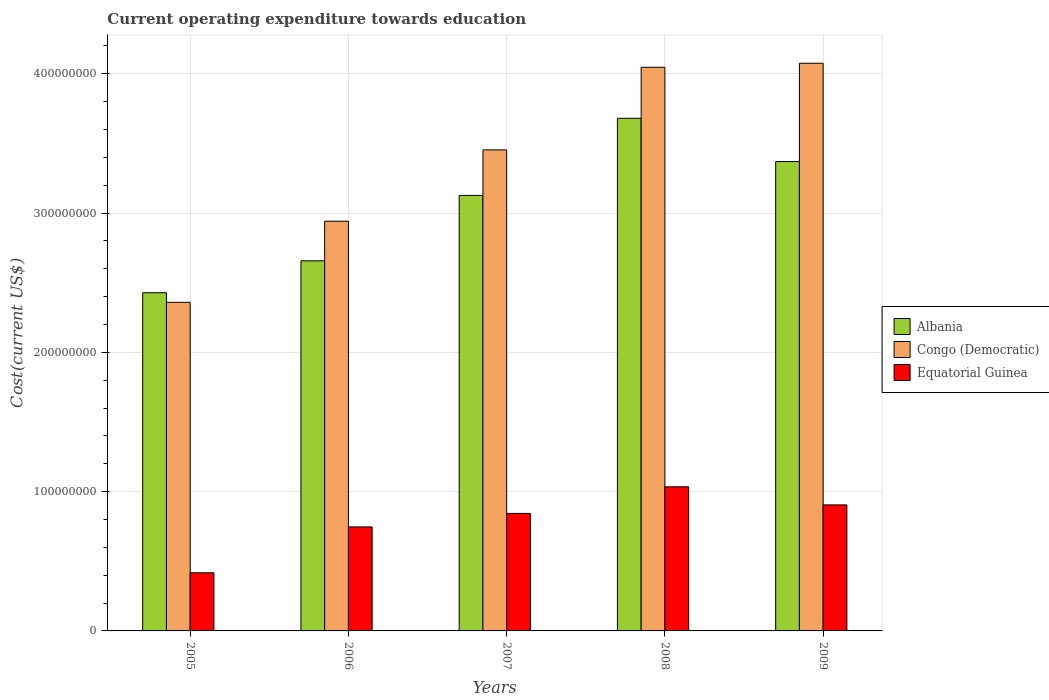How many different coloured bars are there?
Offer a very short reply. 3. How many groups of bars are there?
Give a very brief answer. 5. Are the number of bars per tick equal to the number of legend labels?
Offer a very short reply. Yes. How many bars are there on the 1st tick from the left?
Make the answer very short. 3. What is the label of the 4th group of bars from the left?
Provide a short and direct response. 2008. In how many cases, is the number of bars for a given year not equal to the number of legend labels?
Give a very brief answer. 0. What is the expenditure towards education in Congo (Democratic) in 2009?
Ensure brevity in your answer.  4.08e+08. Across all years, what is the maximum expenditure towards education in Equatorial Guinea?
Offer a terse response. 1.03e+08. Across all years, what is the minimum expenditure towards education in Equatorial Guinea?
Provide a succinct answer. 4.17e+07. In which year was the expenditure towards education in Congo (Democratic) maximum?
Ensure brevity in your answer.  2009. In which year was the expenditure towards education in Equatorial Guinea minimum?
Provide a short and direct response. 2005. What is the total expenditure towards education in Congo (Democratic) in the graph?
Your answer should be compact. 1.69e+09. What is the difference between the expenditure towards education in Albania in 2005 and that in 2007?
Make the answer very short. -6.98e+07. What is the difference between the expenditure towards education in Equatorial Guinea in 2008 and the expenditure towards education in Albania in 2005?
Keep it short and to the point. -1.39e+08. What is the average expenditure towards education in Equatorial Guinea per year?
Offer a terse response. 7.89e+07. In the year 2008, what is the difference between the expenditure towards education in Equatorial Guinea and expenditure towards education in Congo (Democratic)?
Provide a short and direct response. -3.01e+08. What is the ratio of the expenditure towards education in Albania in 2006 to that in 2009?
Your answer should be very brief. 0.79. Is the difference between the expenditure towards education in Equatorial Guinea in 2007 and 2008 greater than the difference between the expenditure towards education in Congo (Democratic) in 2007 and 2008?
Your response must be concise. Yes. What is the difference between the highest and the second highest expenditure towards education in Albania?
Provide a succinct answer. 3.11e+07. What is the difference between the highest and the lowest expenditure towards education in Albania?
Provide a short and direct response. 1.25e+08. Is the sum of the expenditure towards education in Albania in 2005 and 2008 greater than the maximum expenditure towards education in Equatorial Guinea across all years?
Your response must be concise. Yes. What does the 3rd bar from the left in 2007 represents?
Your response must be concise. Equatorial Guinea. What does the 2nd bar from the right in 2009 represents?
Keep it short and to the point. Congo (Democratic). Is it the case that in every year, the sum of the expenditure towards education in Congo (Democratic) and expenditure towards education in Albania is greater than the expenditure towards education in Equatorial Guinea?
Provide a succinct answer. Yes. How many bars are there?
Offer a very short reply. 15. Are all the bars in the graph horizontal?
Offer a very short reply. No. Are the values on the major ticks of Y-axis written in scientific E-notation?
Your answer should be very brief. No. Does the graph contain any zero values?
Your answer should be very brief. No. Does the graph contain grids?
Keep it short and to the point. Yes. Where does the legend appear in the graph?
Keep it short and to the point. Center right. How are the legend labels stacked?
Provide a succinct answer. Vertical. What is the title of the graph?
Ensure brevity in your answer.  Current operating expenditure towards education. Does "Netherlands" appear as one of the legend labels in the graph?
Offer a terse response. No. What is the label or title of the Y-axis?
Keep it short and to the point. Cost(current US$). What is the Cost(current US$) of Albania in 2005?
Your answer should be compact. 2.43e+08. What is the Cost(current US$) of Congo (Democratic) in 2005?
Provide a succinct answer. 2.36e+08. What is the Cost(current US$) in Equatorial Guinea in 2005?
Your answer should be compact. 4.17e+07. What is the Cost(current US$) in Albania in 2006?
Your response must be concise. 2.66e+08. What is the Cost(current US$) in Congo (Democratic) in 2006?
Ensure brevity in your answer.  2.94e+08. What is the Cost(current US$) in Equatorial Guinea in 2006?
Offer a very short reply. 7.47e+07. What is the Cost(current US$) in Albania in 2007?
Your answer should be very brief. 3.13e+08. What is the Cost(current US$) of Congo (Democratic) in 2007?
Offer a very short reply. 3.45e+08. What is the Cost(current US$) of Equatorial Guinea in 2007?
Your response must be concise. 8.44e+07. What is the Cost(current US$) in Albania in 2008?
Make the answer very short. 3.68e+08. What is the Cost(current US$) of Congo (Democratic) in 2008?
Keep it short and to the point. 4.05e+08. What is the Cost(current US$) of Equatorial Guinea in 2008?
Provide a short and direct response. 1.03e+08. What is the Cost(current US$) in Albania in 2009?
Keep it short and to the point. 3.37e+08. What is the Cost(current US$) of Congo (Democratic) in 2009?
Provide a succinct answer. 4.08e+08. What is the Cost(current US$) of Equatorial Guinea in 2009?
Your answer should be compact. 9.05e+07. Across all years, what is the maximum Cost(current US$) of Albania?
Your answer should be very brief. 3.68e+08. Across all years, what is the maximum Cost(current US$) of Congo (Democratic)?
Offer a terse response. 4.08e+08. Across all years, what is the maximum Cost(current US$) of Equatorial Guinea?
Offer a very short reply. 1.03e+08. Across all years, what is the minimum Cost(current US$) in Albania?
Make the answer very short. 2.43e+08. Across all years, what is the minimum Cost(current US$) of Congo (Democratic)?
Your response must be concise. 2.36e+08. Across all years, what is the minimum Cost(current US$) in Equatorial Guinea?
Offer a terse response. 4.17e+07. What is the total Cost(current US$) in Albania in the graph?
Provide a short and direct response. 1.53e+09. What is the total Cost(current US$) in Congo (Democratic) in the graph?
Your response must be concise. 1.69e+09. What is the total Cost(current US$) in Equatorial Guinea in the graph?
Your answer should be very brief. 3.95e+08. What is the difference between the Cost(current US$) of Albania in 2005 and that in 2006?
Provide a short and direct response. -2.29e+07. What is the difference between the Cost(current US$) in Congo (Democratic) in 2005 and that in 2006?
Your response must be concise. -5.82e+07. What is the difference between the Cost(current US$) in Equatorial Guinea in 2005 and that in 2006?
Your response must be concise. -3.29e+07. What is the difference between the Cost(current US$) of Albania in 2005 and that in 2007?
Give a very brief answer. -6.98e+07. What is the difference between the Cost(current US$) of Congo (Democratic) in 2005 and that in 2007?
Offer a terse response. -1.09e+08. What is the difference between the Cost(current US$) in Equatorial Guinea in 2005 and that in 2007?
Offer a very short reply. -4.26e+07. What is the difference between the Cost(current US$) of Albania in 2005 and that in 2008?
Ensure brevity in your answer.  -1.25e+08. What is the difference between the Cost(current US$) of Congo (Democratic) in 2005 and that in 2008?
Ensure brevity in your answer.  -1.69e+08. What is the difference between the Cost(current US$) in Equatorial Guinea in 2005 and that in 2008?
Offer a terse response. -6.17e+07. What is the difference between the Cost(current US$) in Albania in 2005 and that in 2009?
Keep it short and to the point. -9.42e+07. What is the difference between the Cost(current US$) of Congo (Democratic) in 2005 and that in 2009?
Make the answer very short. -1.72e+08. What is the difference between the Cost(current US$) in Equatorial Guinea in 2005 and that in 2009?
Offer a very short reply. -4.87e+07. What is the difference between the Cost(current US$) in Albania in 2006 and that in 2007?
Provide a succinct answer. -4.69e+07. What is the difference between the Cost(current US$) of Congo (Democratic) in 2006 and that in 2007?
Your answer should be compact. -5.12e+07. What is the difference between the Cost(current US$) in Equatorial Guinea in 2006 and that in 2007?
Give a very brief answer. -9.70e+06. What is the difference between the Cost(current US$) of Albania in 2006 and that in 2008?
Offer a very short reply. -1.02e+08. What is the difference between the Cost(current US$) in Congo (Democratic) in 2006 and that in 2008?
Offer a terse response. -1.11e+08. What is the difference between the Cost(current US$) in Equatorial Guinea in 2006 and that in 2008?
Your response must be concise. -2.88e+07. What is the difference between the Cost(current US$) of Albania in 2006 and that in 2009?
Ensure brevity in your answer.  -7.13e+07. What is the difference between the Cost(current US$) of Congo (Democratic) in 2006 and that in 2009?
Offer a very short reply. -1.13e+08. What is the difference between the Cost(current US$) of Equatorial Guinea in 2006 and that in 2009?
Your answer should be very brief. -1.58e+07. What is the difference between the Cost(current US$) of Albania in 2007 and that in 2008?
Keep it short and to the point. -5.54e+07. What is the difference between the Cost(current US$) in Congo (Democratic) in 2007 and that in 2008?
Your response must be concise. -5.93e+07. What is the difference between the Cost(current US$) in Equatorial Guinea in 2007 and that in 2008?
Offer a terse response. -1.91e+07. What is the difference between the Cost(current US$) of Albania in 2007 and that in 2009?
Offer a terse response. -2.43e+07. What is the difference between the Cost(current US$) of Congo (Democratic) in 2007 and that in 2009?
Keep it short and to the point. -6.22e+07. What is the difference between the Cost(current US$) of Equatorial Guinea in 2007 and that in 2009?
Keep it short and to the point. -6.12e+06. What is the difference between the Cost(current US$) in Albania in 2008 and that in 2009?
Keep it short and to the point. 3.11e+07. What is the difference between the Cost(current US$) of Congo (Democratic) in 2008 and that in 2009?
Ensure brevity in your answer.  -2.88e+06. What is the difference between the Cost(current US$) in Equatorial Guinea in 2008 and that in 2009?
Give a very brief answer. 1.30e+07. What is the difference between the Cost(current US$) of Albania in 2005 and the Cost(current US$) of Congo (Democratic) in 2006?
Make the answer very short. -5.13e+07. What is the difference between the Cost(current US$) of Albania in 2005 and the Cost(current US$) of Equatorial Guinea in 2006?
Ensure brevity in your answer.  1.68e+08. What is the difference between the Cost(current US$) of Congo (Democratic) in 2005 and the Cost(current US$) of Equatorial Guinea in 2006?
Offer a terse response. 1.61e+08. What is the difference between the Cost(current US$) in Albania in 2005 and the Cost(current US$) in Congo (Democratic) in 2007?
Offer a very short reply. -1.03e+08. What is the difference between the Cost(current US$) in Albania in 2005 and the Cost(current US$) in Equatorial Guinea in 2007?
Your answer should be compact. 1.58e+08. What is the difference between the Cost(current US$) of Congo (Democratic) in 2005 and the Cost(current US$) of Equatorial Guinea in 2007?
Your answer should be compact. 1.52e+08. What is the difference between the Cost(current US$) of Albania in 2005 and the Cost(current US$) of Congo (Democratic) in 2008?
Ensure brevity in your answer.  -1.62e+08. What is the difference between the Cost(current US$) of Albania in 2005 and the Cost(current US$) of Equatorial Guinea in 2008?
Offer a very short reply. 1.39e+08. What is the difference between the Cost(current US$) of Congo (Democratic) in 2005 and the Cost(current US$) of Equatorial Guinea in 2008?
Provide a succinct answer. 1.32e+08. What is the difference between the Cost(current US$) in Albania in 2005 and the Cost(current US$) in Congo (Democratic) in 2009?
Your response must be concise. -1.65e+08. What is the difference between the Cost(current US$) in Albania in 2005 and the Cost(current US$) in Equatorial Guinea in 2009?
Offer a terse response. 1.52e+08. What is the difference between the Cost(current US$) of Congo (Democratic) in 2005 and the Cost(current US$) of Equatorial Guinea in 2009?
Give a very brief answer. 1.45e+08. What is the difference between the Cost(current US$) in Albania in 2006 and the Cost(current US$) in Congo (Democratic) in 2007?
Keep it short and to the point. -7.96e+07. What is the difference between the Cost(current US$) in Albania in 2006 and the Cost(current US$) in Equatorial Guinea in 2007?
Your response must be concise. 1.81e+08. What is the difference between the Cost(current US$) in Congo (Democratic) in 2006 and the Cost(current US$) in Equatorial Guinea in 2007?
Your answer should be very brief. 2.10e+08. What is the difference between the Cost(current US$) of Albania in 2006 and the Cost(current US$) of Congo (Democratic) in 2008?
Your response must be concise. -1.39e+08. What is the difference between the Cost(current US$) of Albania in 2006 and the Cost(current US$) of Equatorial Guinea in 2008?
Make the answer very short. 1.62e+08. What is the difference between the Cost(current US$) of Congo (Democratic) in 2006 and the Cost(current US$) of Equatorial Guinea in 2008?
Offer a very short reply. 1.91e+08. What is the difference between the Cost(current US$) in Albania in 2006 and the Cost(current US$) in Congo (Democratic) in 2009?
Offer a very short reply. -1.42e+08. What is the difference between the Cost(current US$) of Albania in 2006 and the Cost(current US$) of Equatorial Guinea in 2009?
Provide a short and direct response. 1.75e+08. What is the difference between the Cost(current US$) of Congo (Democratic) in 2006 and the Cost(current US$) of Equatorial Guinea in 2009?
Ensure brevity in your answer.  2.04e+08. What is the difference between the Cost(current US$) of Albania in 2007 and the Cost(current US$) of Congo (Democratic) in 2008?
Make the answer very short. -9.20e+07. What is the difference between the Cost(current US$) in Albania in 2007 and the Cost(current US$) in Equatorial Guinea in 2008?
Provide a short and direct response. 2.09e+08. What is the difference between the Cost(current US$) of Congo (Democratic) in 2007 and the Cost(current US$) of Equatorial Guinea in 2008?
Offer a very short reply. 2.42e+08. What is the difference between the Cost(current US$) in Albania in 2007 and the Cost(current US$) in Congo (Democratic) in 2009?
Offer a terse response. -9.49e+07. What is the difference between the Cost(current US$) in Albania in 2007 and the Cost(current US$) in Equatorial Guinea in 2009?
Provide a short and direct response. 2.22e+08. What is the difference between the Cost(current US$) in Congo (Democratic) in 2007 and the Cost(current US$) in Equatorial Guinea in 2009?
Ensure brevity in your answer.  2.55e+08. What is the difference between the Cost(current US$) of Albania in 2008 and the Cost(current US$) of Congo (Democratic) in 2009?
Your response must be concise. -3.95e+07. What is the difference between the Cost(current US$) in Albania in 2008 and the Cost(current US$) in Equatorial Guinea in 2009?
Your answer should be very brief. 2.78e+08. What is the difference between the Cost(current US$) of Congo (Democratic) in 2008 and the Cost(current US$) of Equatorial Guinea in 2009?
Give a very brief answer. 3.14e+08. What is the average Cost(current US$) of Albania per year?
Your answer should be very brief. 3.05e+08. What is the average Cost(current US$) in Congo (Democratic) per year?
Your answer should be very brief. 3.38e+08. What is the average Cost(current US$) of Equatorial Guinea per year?
Offer a very short reply. 7.89e+07. In the year 2005, what is the difference between the Cost(current US$) in Albania and Cost(current US$) in Congo (Democratic)?
Provide a short and direct response. 6.89e+06. In the year 2005, what is the difference between the Cost(current US$) in Albania and Cost(current US$) in Equatorial Guinea?
Provide a succinct answer. 2.01e+08. In the year 2005, what is the difference between the Cost(current US$) of Congo (Democratic) and Cost(current US$) of Equatorial Guinea?
Make the answer very short. 1.94e+08. In the year 2006, what is the difference between the Cost(current US$) of Albania and Cost(current US$) of Congo (Democratic)?
Your response must be concise. -2.84e+07. In the year 2006, what is the difference between the Cost(current US$) in Albania and Cost(current US$) in Equatorial Guinea?
Ensure brevity in your answer.  1.91e+08. In the year 2006, what is the difference between the Cost(current US$) in Congo (Democratic) and Cost(current US$) in Equatorial Guinea?
Give a very brief answer. 2.19e+08. In the year 2007, what is the difference between the Cost(current US$) in Albania and Cost(current US$) in Congo (Democratic)?
Your answer should be very brief. -3.27e+07. In the year 2007, what is the difference between the Cost(current US$) in Albania and Cost(current US$) in Equatorial Guinea?
Provide a succinct answer. 2.28e+08. In the year 2007, what is the difference between the Cost(current US$) in Congo (Democratic) and Cost(current US$) in Equatorial Guinea?
Provide a succinct answer. 2.61e+08. In the year 2008, what is the difference between the Cost(current US$) of Albania and Cost(current US$) of Congo (Democratic)?
Make the answer very short. -3.66e+07. In the year 2008, what is the difference between the Cost(current US$) of Albania and Cost(current US$) of Equatorial Guinea?
Your response must be concise. 2.65e+08. In the year 2008, what is the difference between the Cost(current US$) in Congo (Democratic) and Cost(current US$) in Equatorial Guinea?
Ensure brevity in your answer.  3.01e+08. In the year 2009, what is the difference between the Cost(current US$) of Albania and Cost(current US$) of Congo (Democratic)?
Provide a succinct answer. -7.06e+07. In the year 2009, what is the difference between the Cost(current US$) of Albania and Cost(current US$) of Equatorial Guinea?
Ensure brevity in your answer.  2.46e+08. In the year 2009, what is the difference between the Cost(current US$) in Congo (Democratic) and Cost(current US$) in Equatorial Guinea?
Your response must be concise. 3.17e+08. What is the ratio of the Cost(current US$) in Albania in 2005 to that in 2006?
Offer a very short reply. 0.91. What is the ratio of the Cost(current US$) of Congo (Democratic) in 2005 to that in 2006?
Make the answer very short. 0.8. What is the ratio of the Cost(current US$) of Equatorial Guinea in 2005 to that in 2006?
Provide a succinct answer. 0.56. What is the ratio of the Cost(current US$) of Albania in 2005 to that in 2007?
Ensure brevity in your answer.  0.78. What is the ratio of the Cost(current US$) in Congo (Democratic) in 2005 to that in 2007?
Provide a short and direct response. 0.68. What is the ratio of the Cost(current US$) of Equatorial Guinea in 2005 to that in 2007?
Provide a short and direct response. 0.49. What is the ratio of the Cost(current US$) of Albania in 2005 to that in 2008?
Ensure brevity in your answer.  0.66. What is the ratio of the Cost(current US$) in Congo (Democratic) in 2005 to that in 2008?
Offer a very short reply. 0.58. What is the ratio of the Cost(current US$) in Equatorial Guinea in 2005 to that in 2008?
Your answer should be compact. 0.4. What is the ratio of the Cost(current US$) in Albania in 2005 to that in 2009?
Offer a terse response. 0.72. What is the ratio of the Cost(current US$) of Congo (Democratic) in 2005 to that in 2009?
Offer a very short reply. 0.58. What is the ratio of the Cost(current US$) in Equatorial Guinea in 2005 to that in 2009?
Give a very brief answer. 0.46. What is the ratio of the Cost(current US$) of Albania in 2006 to that in 2007?
Ensure brevity in your answer.  0.85. What is the ratio of the Cost(current US$) of Congo (Democratic) in 2006 to that in 2007?
Offer a terse response. 0.85. What is the ratio of the Cost(current US$) of Equatorial Guinea in 2006 to that in 2007?
Provide a short and direct response. 0.89. What is the ratio of the Cost(current US$) of Albania in 2006 to that in 2008?
Keep it short and to the point. 0.72. What is the ratio of the Cost(current US$) in Congo (Democratic) in 2006 to that in 2008?
Provide a succinct answer. 0.73. What is the ratio of the Cost(current US$) in Equatorial Guinea in 2006 to that in 2008?
Keep it short and to the point. 0.72. What is the ratio of the Cost(current US$) in Albania in 2006 to that in 2009?
Your answer should be compact. 0.79. What is the ratio of the Cost(current US$) in Congo (Democratic) in 2006 to that in 2009?
Provide a succinct answer. 0.72. What is the ratio of the Cost(current US$) in Equatorial Guinea in 2006 to that in 2009?
Your answer should be very brief. 0.83. What is the ratio of the Cost(current US$) of Albania in 2007 to that in 2008?
Offer a very short reply. 0.85. What is the ratio of the Cost(current US$) of Congo (Democratic) in 2007 to that in 2008?
Provide a short and direct response. 0.85. What is the ratio of the Cost(current US$) of Equatorial Guinea in 2007 to that in 2008?
Your response must be concise. 0.82. What is the ratio of the Cost(current US$) in Albania in 2007 to that in 2009?
Your answer should be very brief. 0.93. What is the ratio of the Cost(current US$) in Congo (Democratic) in 2007 to that in 2009?
Provide a succinct answer. 0.85. What is the ratio of the Cost(current US$) of Equatorial Guinea in 2007 to that in 2009?
Provide a short and direct response. 0.93. What is the ratio of the Cost(current US$) in Albania in 2008 to that in 2009?
Offer a very short reply. 1.09. What is the ratio of the Cost(current US$) of Equatorial Guinea in 2008 to that in 2009?
Offer a terse response. 1.14. What is the difference between the highest and the second highest Cost(current US$) in Albania?
Your answer should be very brief. 3.11e+07. What is the difference between the highest and the second highest Cost(current US$) of Congo (Democratic)?
Provide a succinct answer. 2.88e+06. What is the difference between the highest and the second highest Cost(current US$) in Equatorial Guinea?
Give a very brief answer. 1.30e+07. What is the difference between the highest and the lowest Cost(current US$) in Albania?
Your answer should be compact. 1.25e+08. What is the difference between the highest and the lowest Cost(current US$) of Congo (Democratic)?
Give a very brief answer. 1.72e+08. What is the difference between the highest and the lowest Cost(current US$) of Equatorial Guinea?
Make the answer very short. 6.17e+07. 